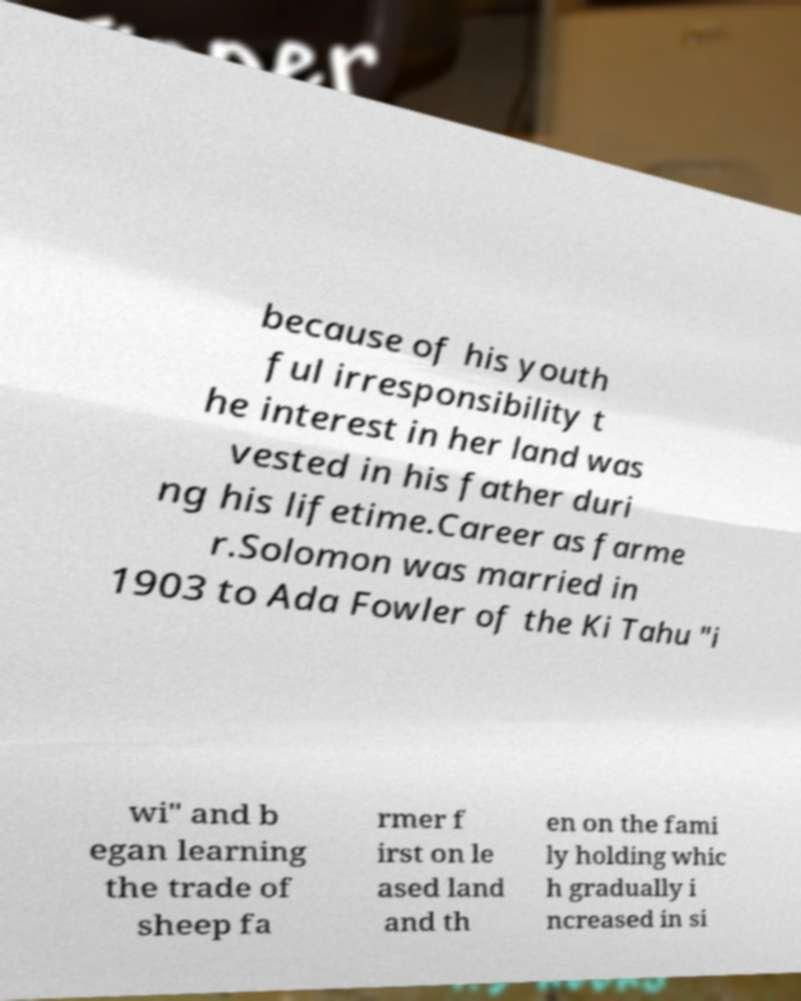Please identify and transcribe the text found in this image. because of his youth ful irresponsibility t he interest in her land was vested in his father duri ng his lifetime.Career as farme r.Solomon was married in 1903 to Ada Fowler of the Ki Tahu "i wi" and b egan learning the trade of sheep fa rmer f irst on le ased land and th en on the fami ly holding whic h gradually i ncreased in si 